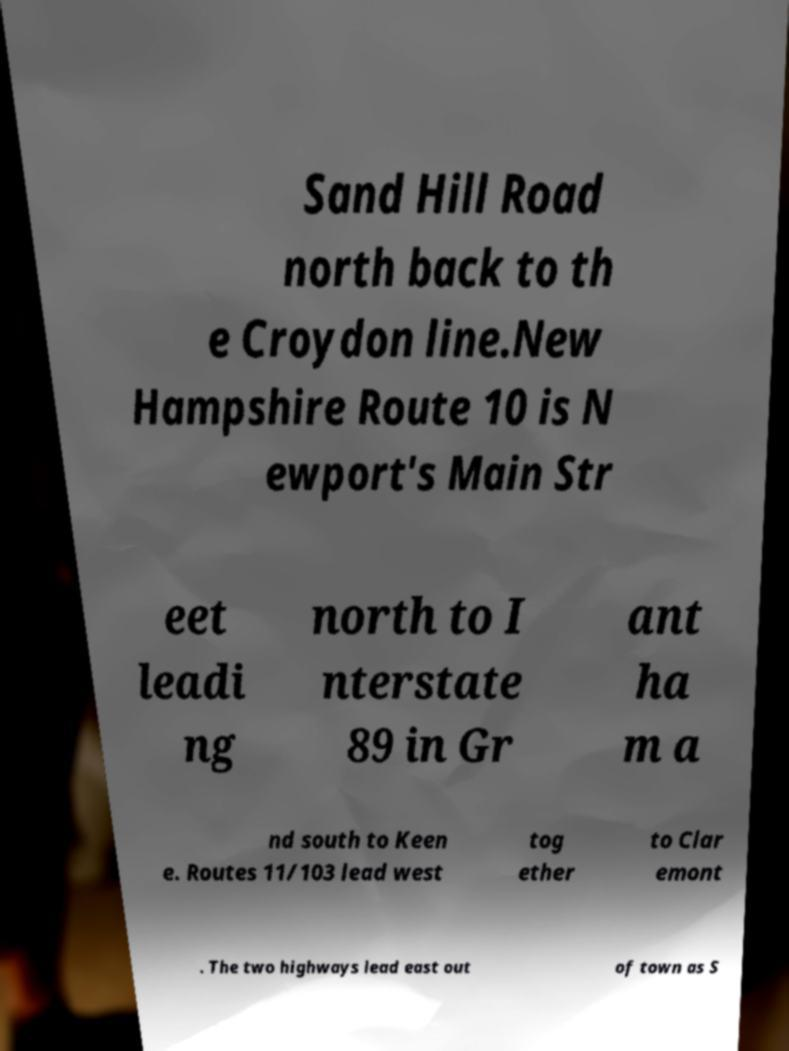Could you extract and type out the text from this image? Sand Hill Road north back to th e Croydon line.New Hampshire Route 10 is N ewport's Main Str eet leadi ng north to I nterstate 89 in Gr ant ha m a nd south to Keen e. Routes 11/103 lead west tog ether to Clar emont . The two highways lead east out of town as S 